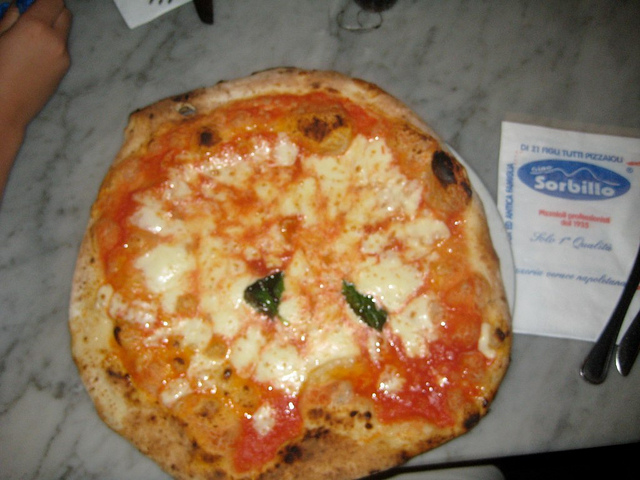Please transcribe the text in this image. Sorbillo 